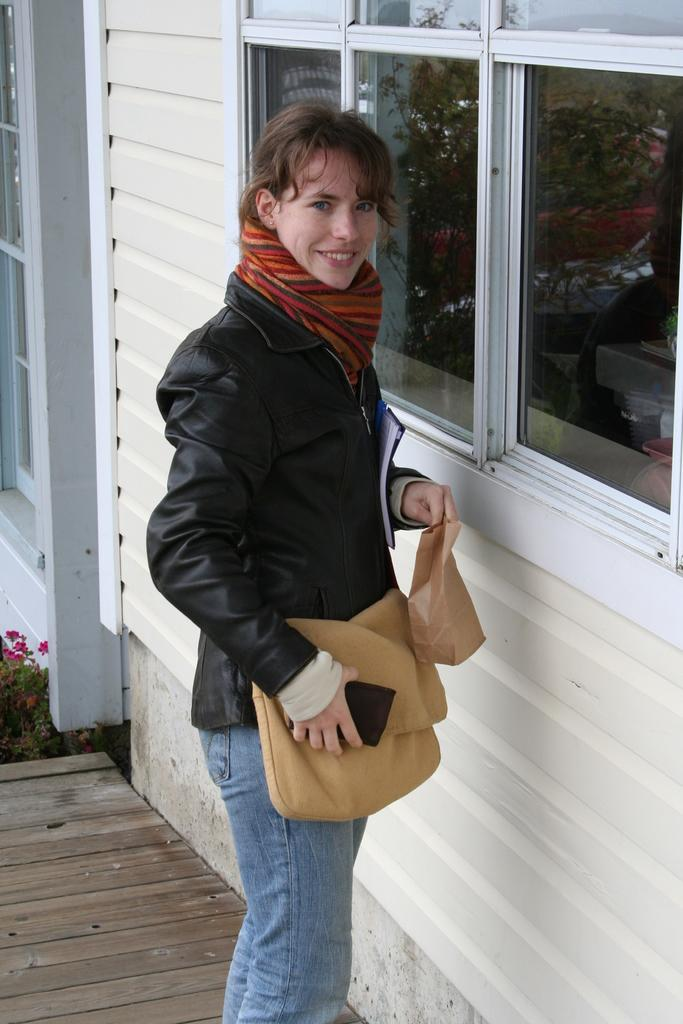Who is present in the image? There is a woman in the image. What is the woman wearing? The woman is wearing a jacket. What expression does the woman have? The woman is smiling. What can be seen in front of the woman? There are windows in front of the woman. How many teeth can be seen in the woman's smile in the image? The number of teeth in the woman's smile cannot be determined from the image, as it does not provide a close-up view of her teeth. 